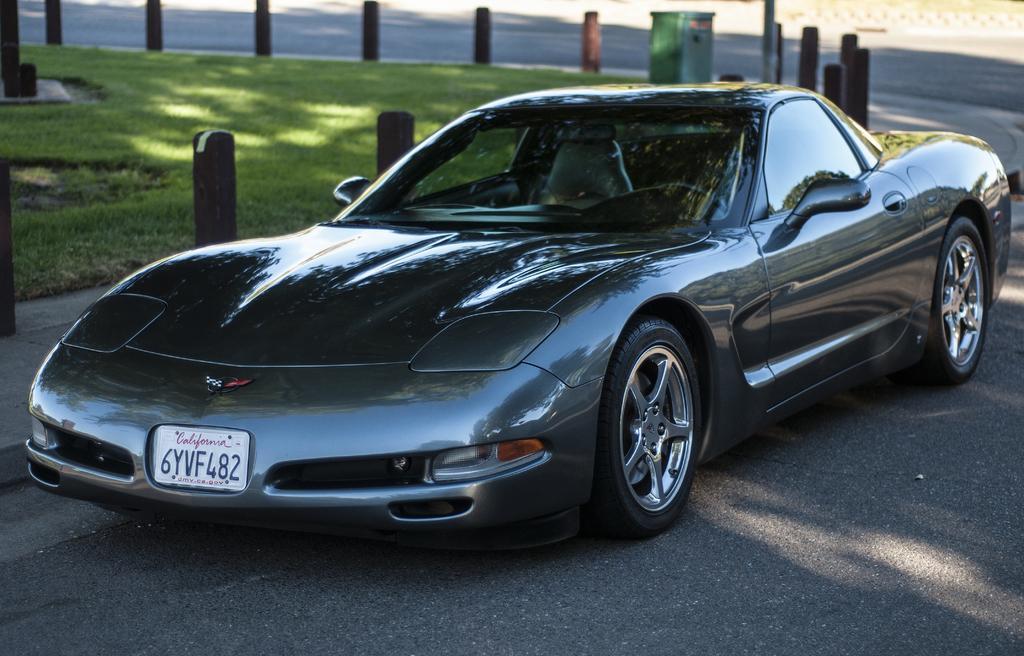How would you summarize this image in a sentence or two? In this picture we can see car on the road and we can see poles, grass and green object. 